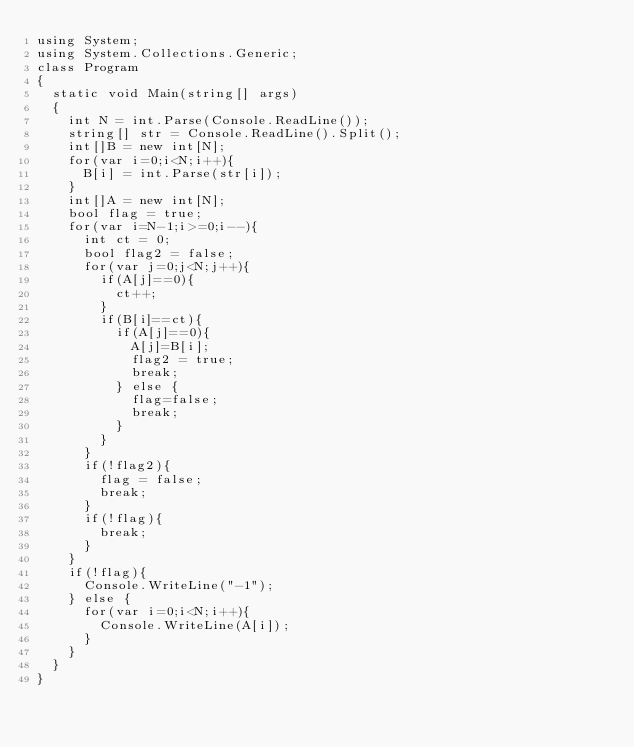Convert code to text. <code><loc_0><loc_0><loc_500><loc_500><_C#_>using System;
using System.Collections.Generic;
class Program
{
	static void Main(string[] args)
	{
		int N = int.Parse(Console.ReadLine());
		string[] str = Console.ReadLine().Split();
		int[]B = new int[N];
		for(var i=0;i<N;i++){
			B[i] = int.Parse(str[i]);
		}
		int[]A = new int[N];
		bool flag = true;
		for(var i=N-1;i>=0;i--){
			int ct = 0;
			bool flag2 = false;
			for(var j=0;j<N;j++){
				if(A[j]==0){
					ct++;
				}
				if(B[i]==ct){
					if(A[j]==0){
						A[j]=B[i];
						flag2 = true;
						break;
					} else {
						flag=false;
						break;
					}
				}
			}
			if(!flag2){
				flag = false;
				break;
			}
			if(!flag){
				break;
			}
		}
		if(!flag){
			Console.WriteLine("-1");
		} else {
			for(var i=0;i<N;i++){
				Console.WriteLine(A[i]);
			}
		}
	}
}</code> 